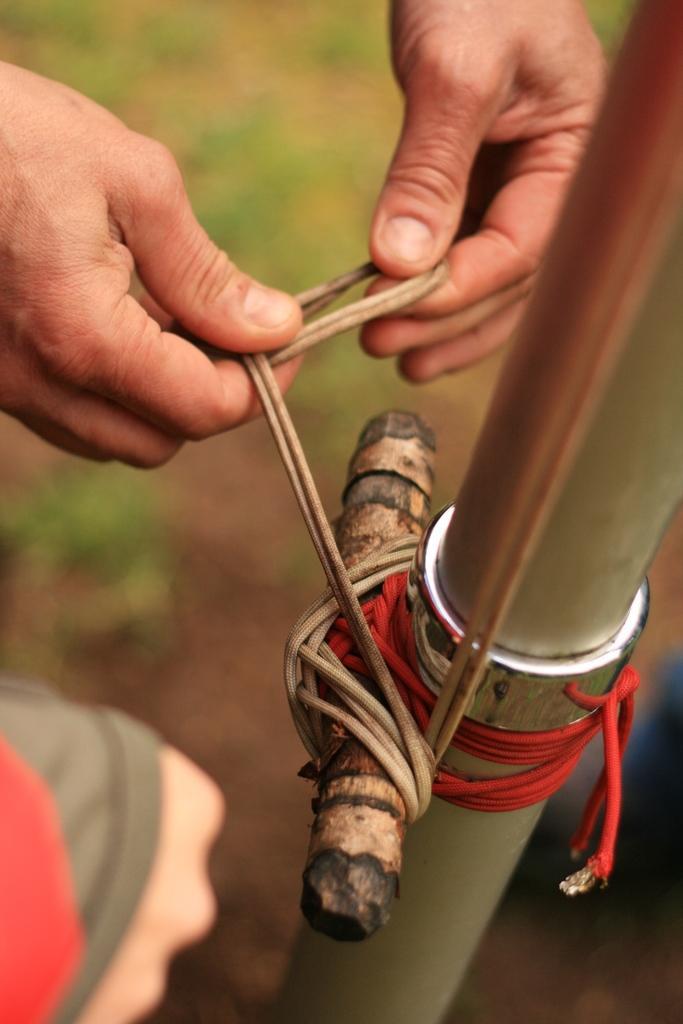How would you summarize this image in a sentence or two? In the picture we can see a person hand tying something to the pole with a wire and near to it we can see another person hand. 